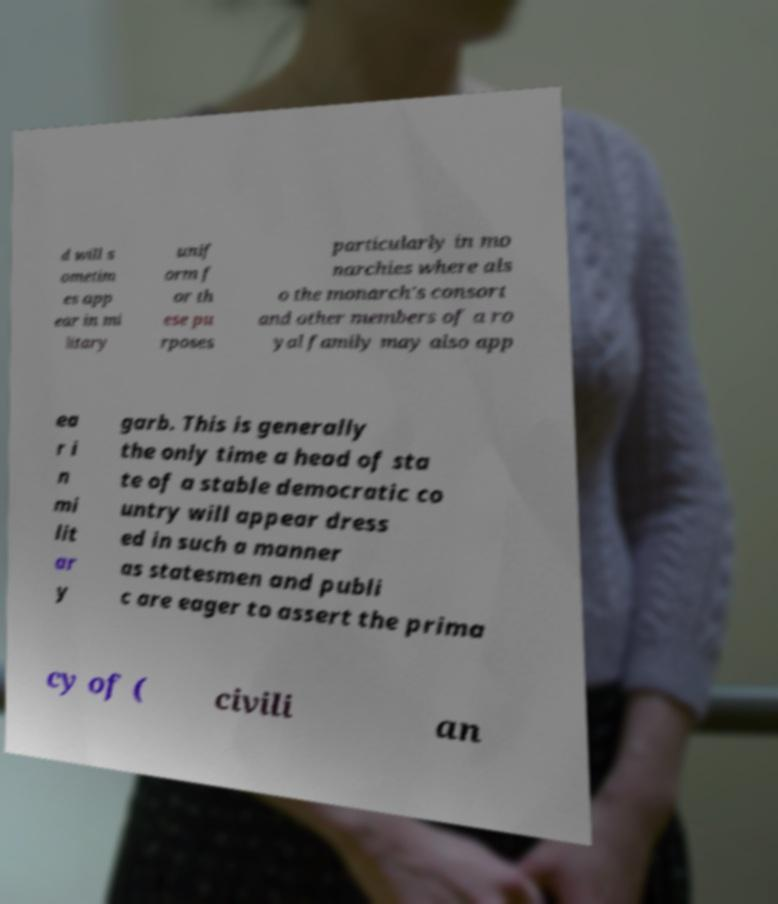I need the written content from this picture converted into text. Can you do that? d will s ometim es app ear in mi litary unif orm f or th ese pu rposes particularly in mo narchies where als o the monarch's consort and other members of a ro yal family may also app ea r i n mi lit ar y garb. This is generally the only time a head of sta te of a stable democratic co untry will appear dress ed in such a manner as statesmen and publi c are eager to assert the prima cy of ( civili an 